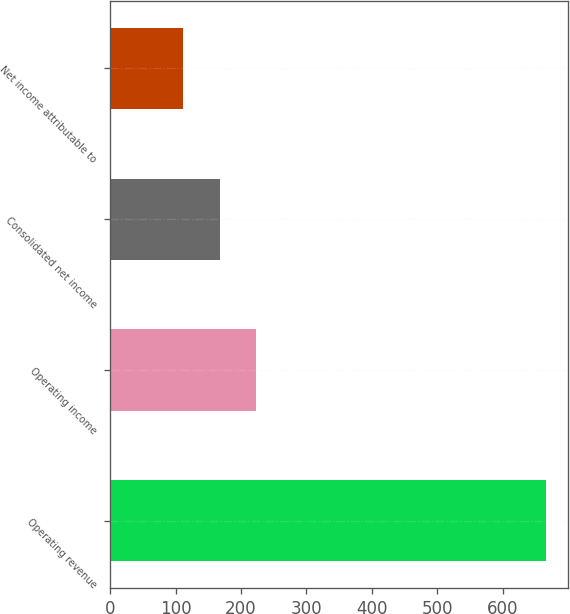Convert chart to OTSL. <chart><loc_0><loc_0><loc_500><loc_500><bar_chart><fcel>Operating revenue<fcel>Operating income<fcel>Consolidated net income<fcel>Net income attributable to<nl><fcel>666.3<fcel>222.78<fcel>167.34<fcel>111.9<nl></chart> 